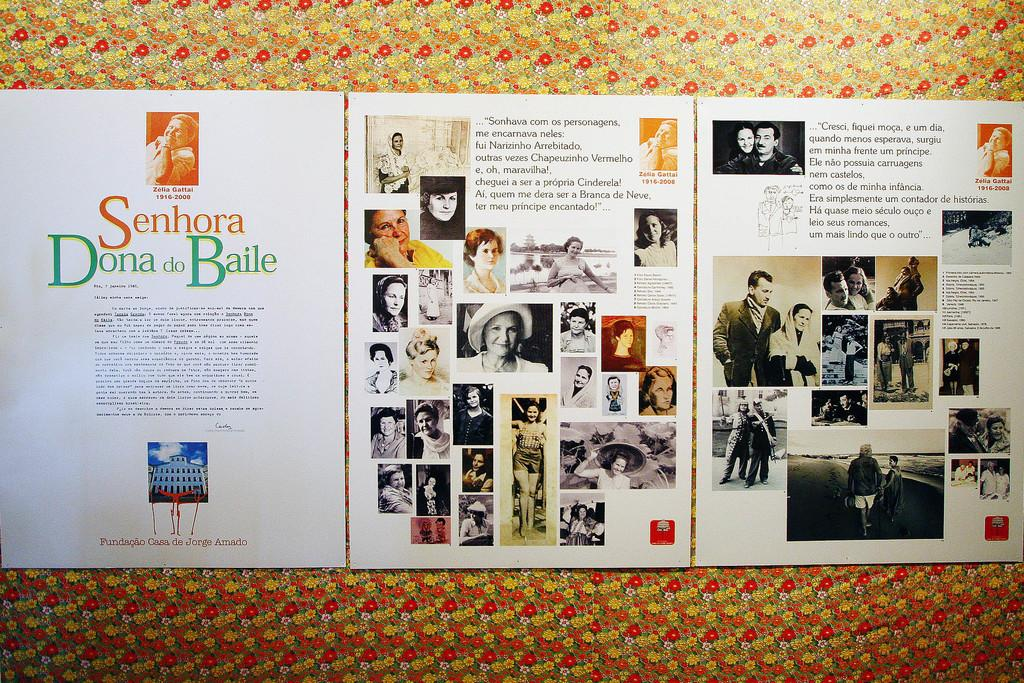<image>
Share a concise interpretation of the image provided. A paper that has the words Senhor Dona Baile on it. 